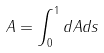<formula> <loc_0><loc_0><loc_500><loc_500>A = \int _ { 0 } ^ { 1 } d A d s</formula> 